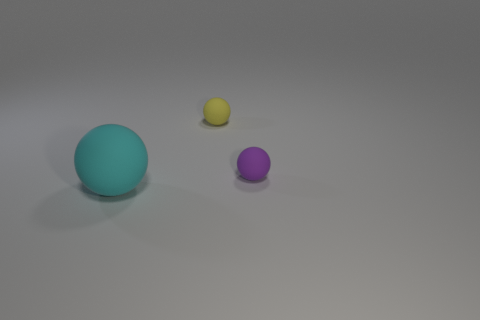How many small matte objects have the same color as the big matte ball?
Your answer should be compact. 0. There is a tiny yellow thing that is the same material as the cyan thing; what is its shape?
Your answer should be very brief. Sphere. What is the size of the matte ball that is on the left side of the yellow ball?
Offer a very short reply. Large. Is the number of tiny matte things right of the large cyan matte sphere the same as the number of cyan things behind the small purple matte object?
Provide a short and direct response. No. There is a small rubber object to the left of the tiny rubber object in front of the small ball left of the tiny purple ball; what color is it?
Offer a terse response. Yellow. How many spheres are both on the left side of the purple rubber ball and behind the cyan matte thing?
Your answer should be very brief. 1. There is a sphere in front of the small purple matte ball; is its color the same as the tiny sphere to the right of the yellow rubber ball?
Offer a terse response. No. There is a cyan rubber thing that is the same shape as the yellow matte object; what size is it?
Your response must be concise. Large. Are there any small yellow balls to the left of the large cyan matte object?
Make the answer very short. No. Is the number of cyan matte things that are to the right of the yellow matte object the same as the number of large cyan things?
Your response must be concise. No. 